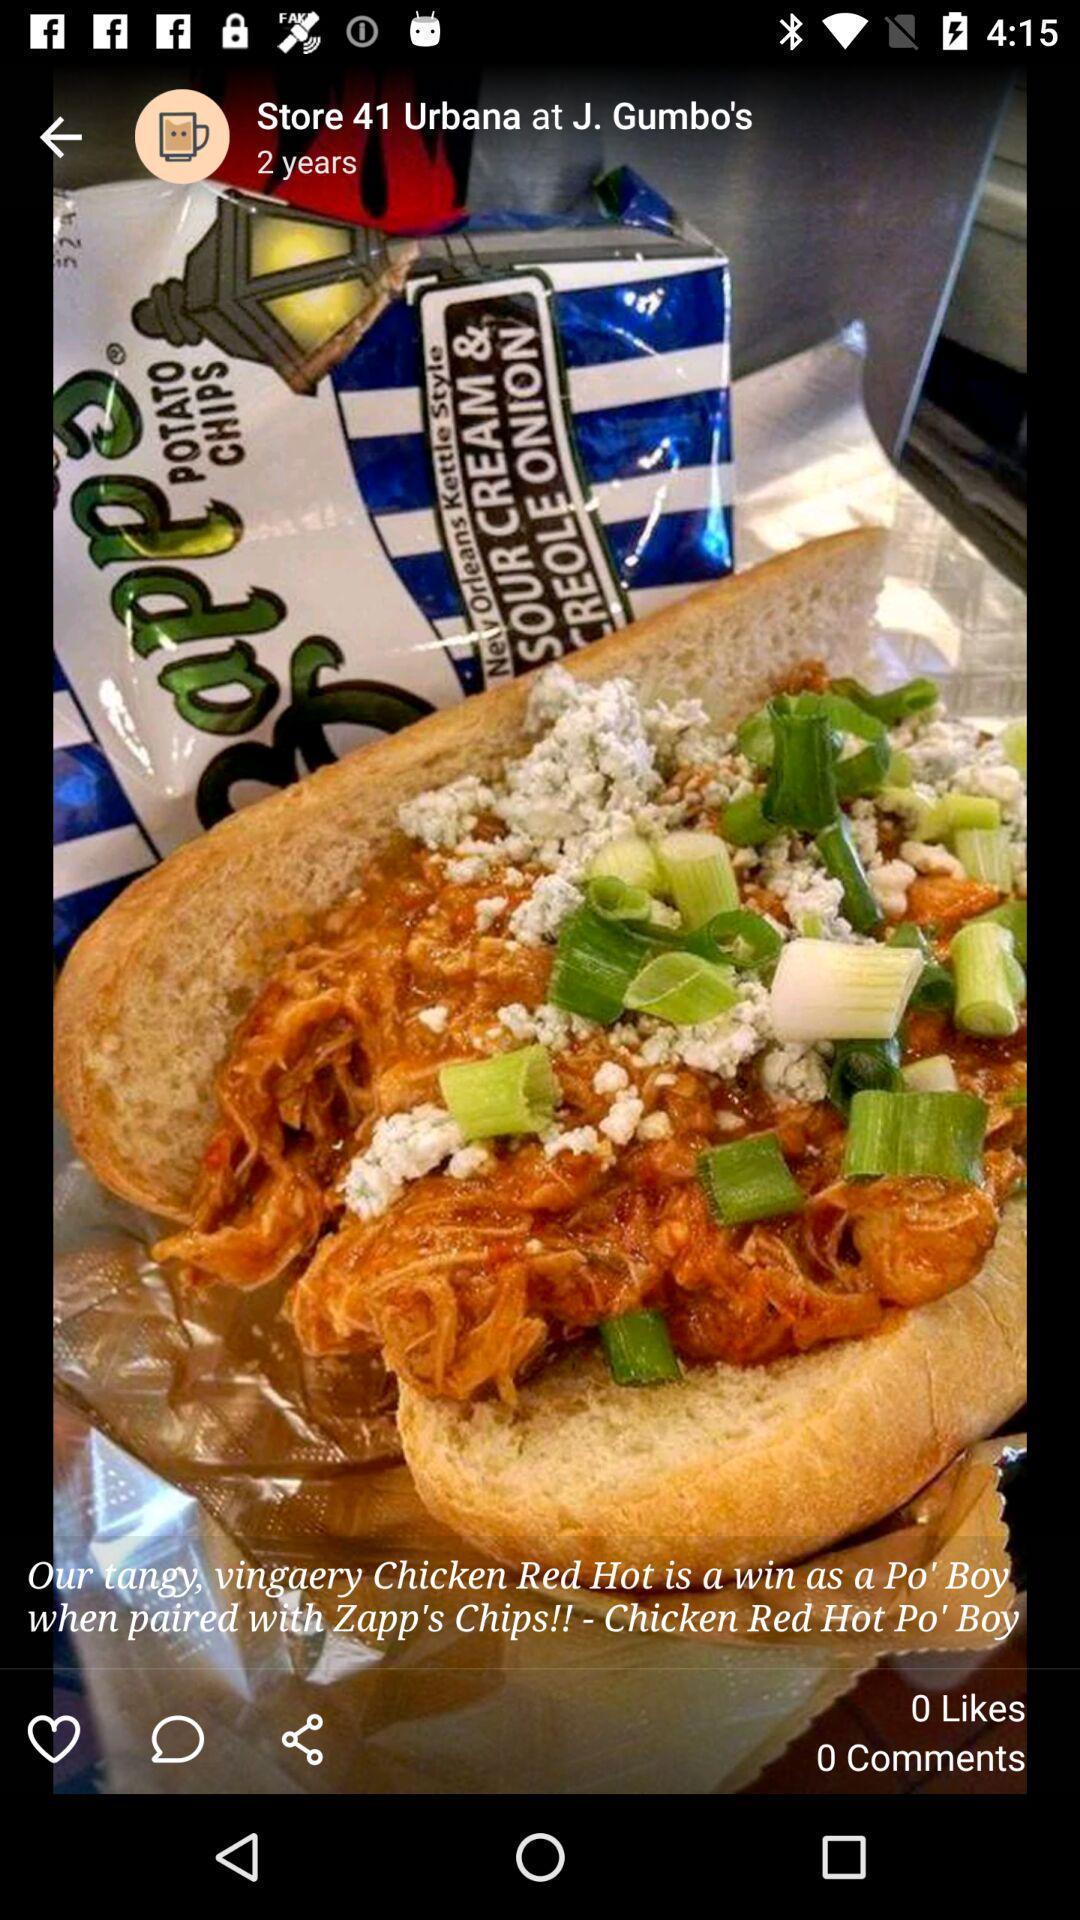Describe this image in words. Screen showing image of food in food ordering app. 